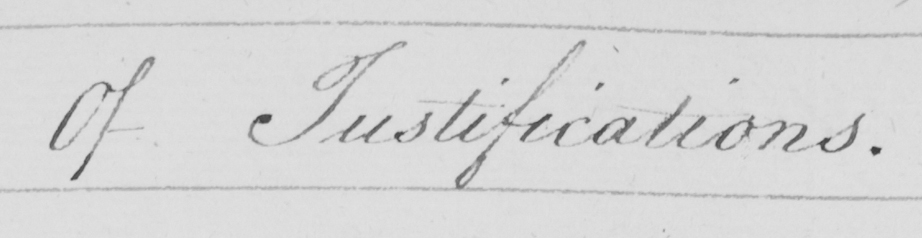Please provide the text content of this handwritten line. Of Justifications . 